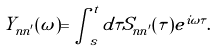<formula> <loc_0><loc_0><loc_500><loc_500>Y _ { n n ^ { \prime } } ( \omega ) = \int _ { s } ^ { t } d \tau S _ { n n ^ { \prime } } ( \tau ) e ^ { i \omega \tau } .</formula> 